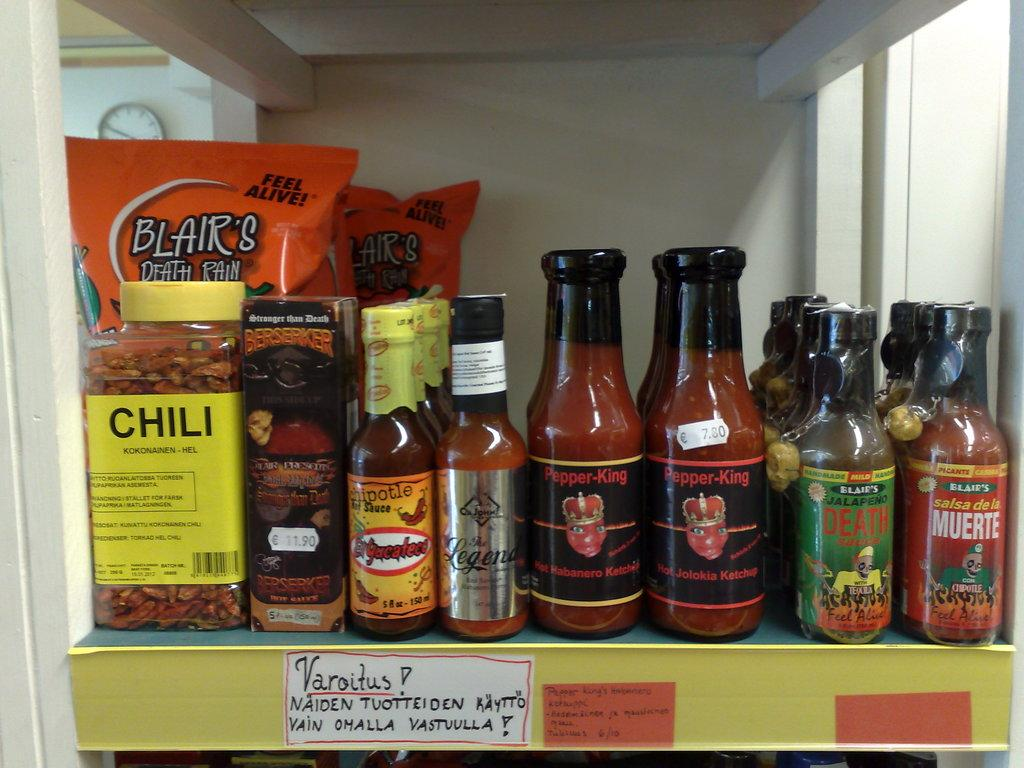What can be seen in the image that is used for storage? There is a shelf in the image that is used for storage. What is stored on the shelf? The shelf contains many bottles. What is inside the bottles? The bottles have liquid in them. Are there any additional features on the bottles? Yes, there are stickers on the bottles. What information is provided by the stickers? The stickers have text on them. What type of ice can be seen melting on the land in the image? There is no ice or land present in the image; it features a shelf with bottles and stickers. 